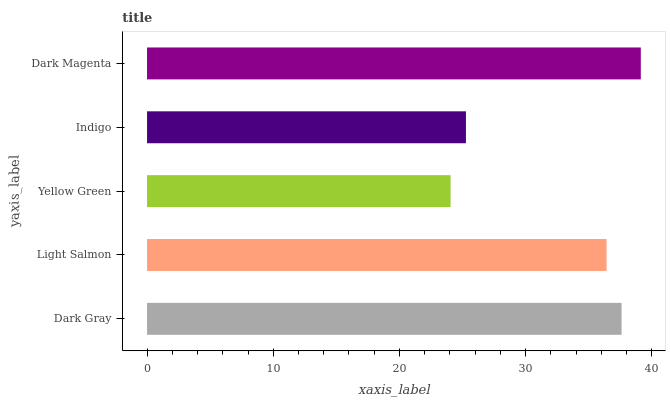Is Yellow Green the minimum?
Answer yes or no. Yes. Is Dark Magenta the maximum?
Answer yes or no. Yes. Is Light Salmon the minimum?
Answer yes or no. No. Is Light Salmon the maximum?
Answer yes or no. No. Is Dark Gray greater than Light Salmon?
Answer yes or no. Yes. Is Light Salmon less than Dark Gray?
Answer yes or no. Yes. Is Light Salmon greater than Dark Gray?
Answer yes or no. No. Is Dark Gray less than Light Salmon?
Answer yes or no. No. Is Light Salmon the high median?
Answer yes or no. Yes. Is Light Salmon the low median?
Answer yes or no. Yes. Is Yellow Green the high median?
Answer yes or no. No. Is Yellow Green the low median?
Answer yes or no. No. 